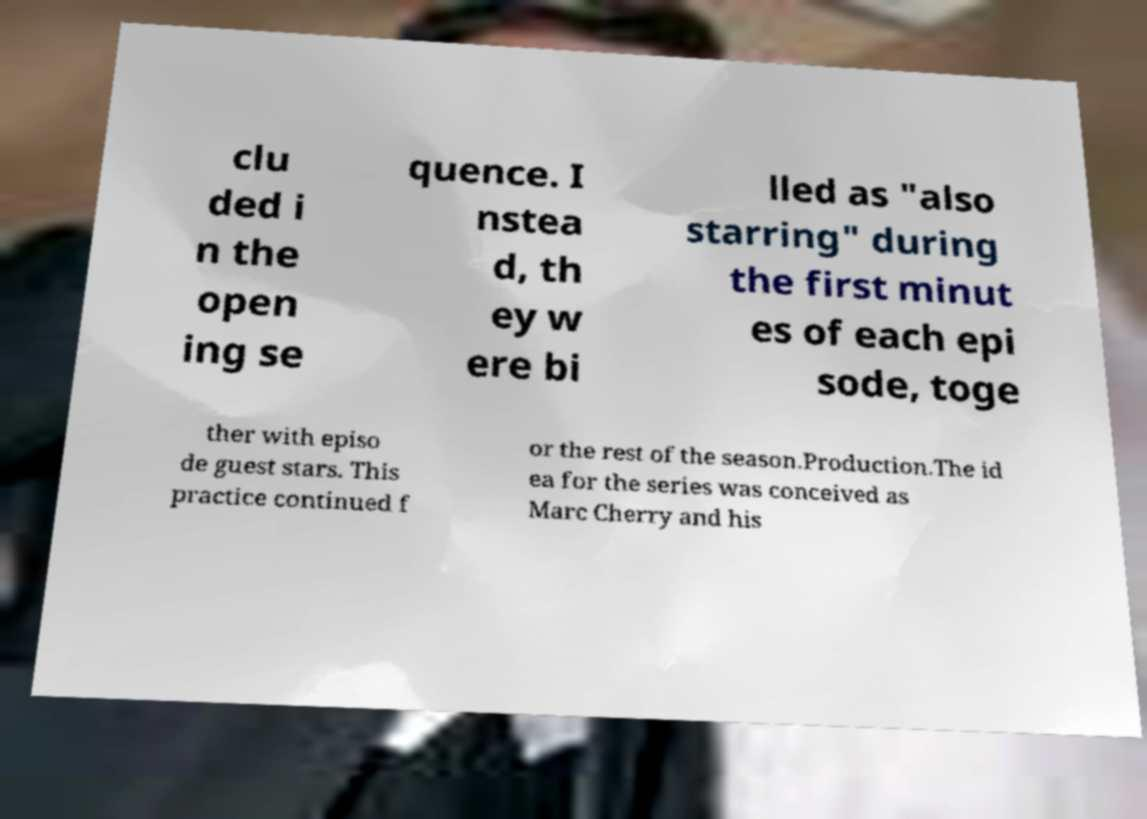Can you accurately transcribe the text from the provided image for me? clu ded i n the open ing se quence. I nstea d, th ey w ere bi lled as "also starring" during the first minut es of each epi sode, toge ther with episo de guest stars. This practice continued f or the rest of the season.Production.The id ea for the series was conceived as Marc Cherry and his 